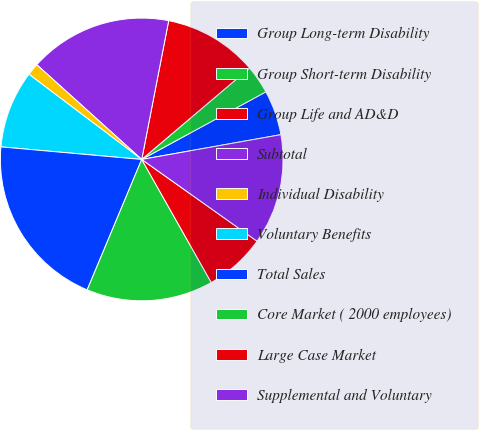Convert chart. <chart><loc_0><loc_0><loc_500><loc_500><pie_chart><fcel>Group Long-term Disability<fcel>Group Short-term Disability<fcel>Group Life and AD&D<fcel>Subtotal<fcel>Individual Disability<fcel>Voluntary Benefits<fcel>Total Sales<fcel>Core Market ( 2000 employees)<fcel>Large Case Market<fcel>Supplemental and Voluntary<nl><fcel>5.13%<fcel>3.26%<fcel>10.75%<fcel>16.37%<fcel>1.39%<fcel>8.88%<fcel>20.11%<fcel>14.49%<fcel>7.0%<fcel>12.62%<nl></chart> 